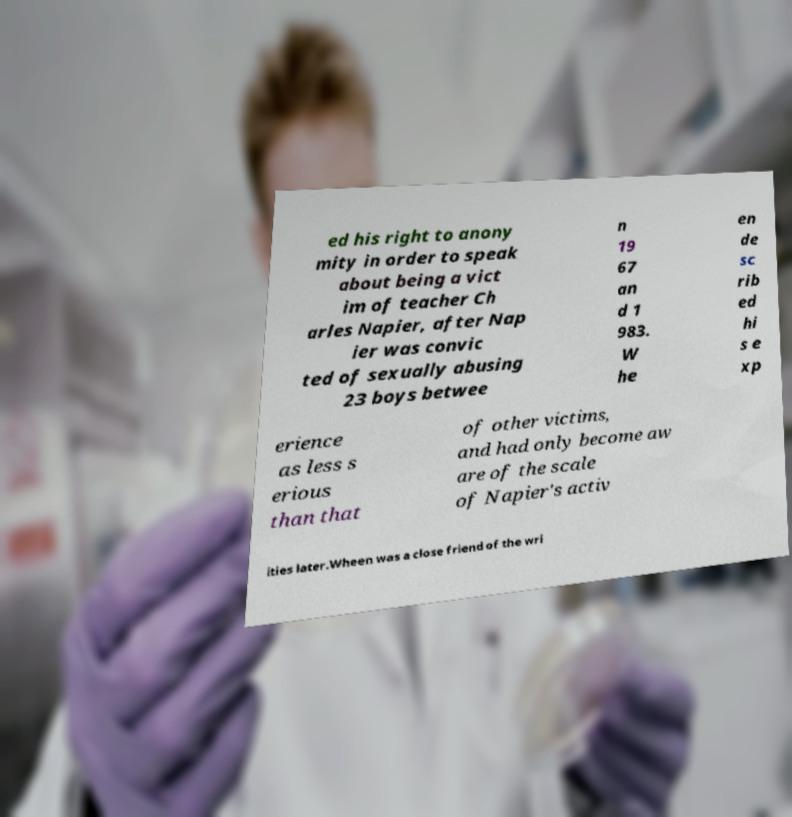There's text embedded in this image that I need extracted. Can you transcribe it verbatim? ed his right to anony mity in order to speak about being a vict im of teacher Ch arles Napier, after Nap ier was convic ted of sexually abusing 23 boys betwee n 19 67 an d 1 983. W he en de sc rib ed hi s e xp erience as less s erious than that of other victims, and had only become aw are of the scale of Napier's activ ities later.Wheen was a close friend of the wri 